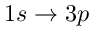Convert formula to latex. <formula><loc_0><loc_0><loc_500><loc_500>1 s \rightarrow 3 p</formula> 